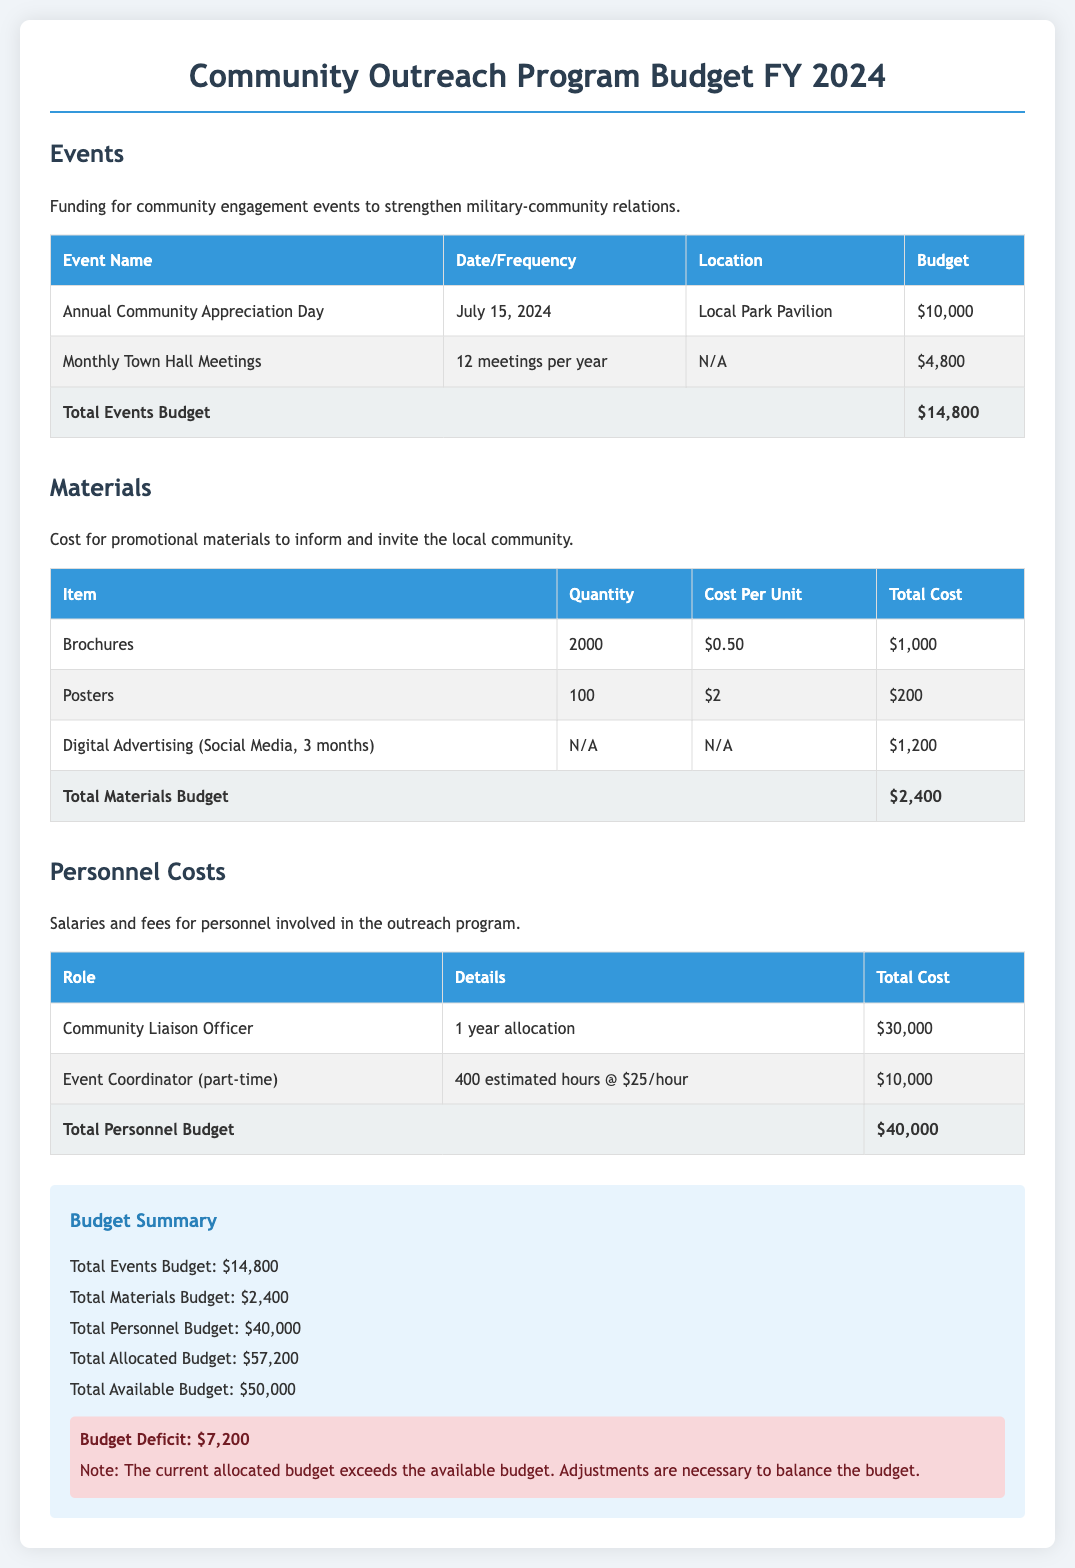What is the date of the Annual Community Appreciation Day? The date for the Annual Community Appreciation Day is explicitly stated in the document.
Answer: July 15, 2024 What is the total budget allocated for events? The total budget for events can be found in the Events section of the budget summary.
Answer: $14,800 How many town hall meetings will be held per year? The frequency of the town hall meetings is specified in the events table.
Answer: 12 meetings per year What is the total cost for brochures? The total cost for brochures is calculated based on the quantity and cost per unit stated in the Materials section.
Answer: $1,000 Who is the Community Liaison Officer? The role of Community Liaison Officer is mentioned in the personnel costs section, identifying a specific position.
Answer: Community Liaison Officer What is the total allocated budget for the Community Outreach Program? The total allocated budget is summarized in the budget summary section of the document.
Answer: $57,200 What is the budget deficit? The document indicates the budget deficit under the budget summary alert section.
Answer: $7,200 What percentage of the budget is allocated to personnel costs? The personnel costs total and the overall budget are both included in the summary for percentage calculation.
Answer: 69.91% What materials are being used for digital advertising? The type of materials for digital advertising is described in the Materials budget section.
Answer: Digital Advertising (Social Media, 3 months) 